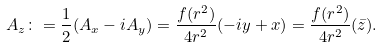Convert formula to latex. <formula><loc_0><loc_0><loc_500><loc_500>A _ { z } \colon = \frac { 1 } { 2 } ( A _ { x } - i A _ { y } ) = \frac { f ( r ^ { 2 } ) } { 4 r ^ { 2 } } ( - i y + x ) = \frac { f ( r ^ { 2 } ) } { 4 r ^ { 2 } } ( \bar { z } ) .</formula> 